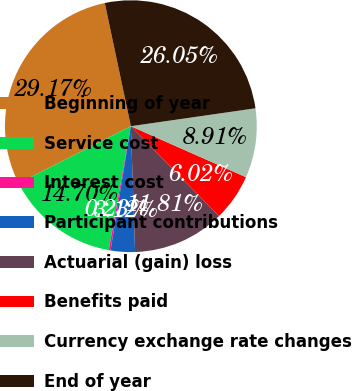Convert chart to OTSL. <chart><loc_0><loc_0><loc_500><loc_500><pie_chart><fcel>Beginning of year<fcel>Service cost<fcel>Interest cost<fcel>Participant contributions<fcel>Actuarial (gain) loss<fcel>Benefits paid<fcel>Currency exchange rate changes<fcel>End of year<nl><fcel>29.17%<fcel>14.7%<fcel>0.23%<fcel>3.12%<fcel>11.81%<fcel>6.02%<fcel>8.91%<fcel>26.05%<nl></chart> 